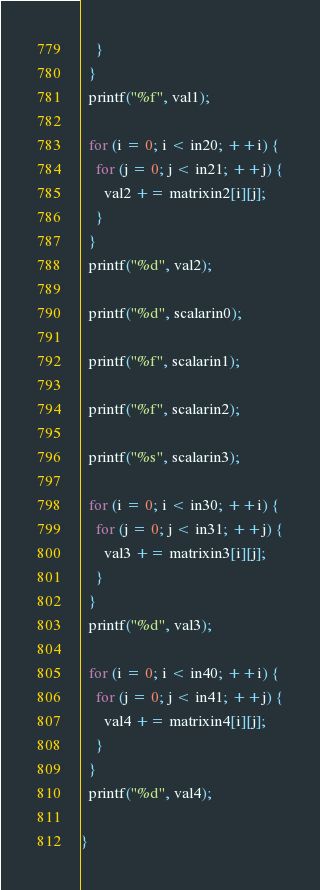Convert code to text. <code><loc_0><loc_0><loc_500><loc_500><_C_>    }
  }
  printf("%f", val1);

  for (i = 0; i < in20; ++i) {
    for (j = 0; j < in21; ++j) {
      val2 += matrixin2[i][j];
    }
  }
  printf("%d", val2);

  printf("%d", scalarin0);

  printf("%f", scalarin1);

  printf("%f", scalarin2);

  printf("%s", scalarin3);

  for (i = 0; i < in30; ++i) {
    for (j = 0; j < in31; ++j) {
      val3 += matrixin3[i][j];
    }
  }
  printf("%d", val3);

  for (i = 0; i < in40; ++i) {
    for (j = 0; j < in41; ++j) {
      val4 += matrixin4[i][j];
    }
  }
  printf("%d", val4);

}
</code> 